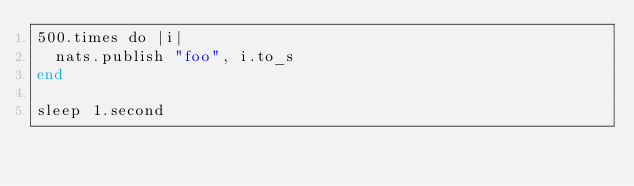Convert code to text. <code><loc_0><loc_0><loc_500><loc_500><_Crystal_>500.times do |i|
  nats.publish "foo", i.to_s
end

sleep 1.second
</code> 